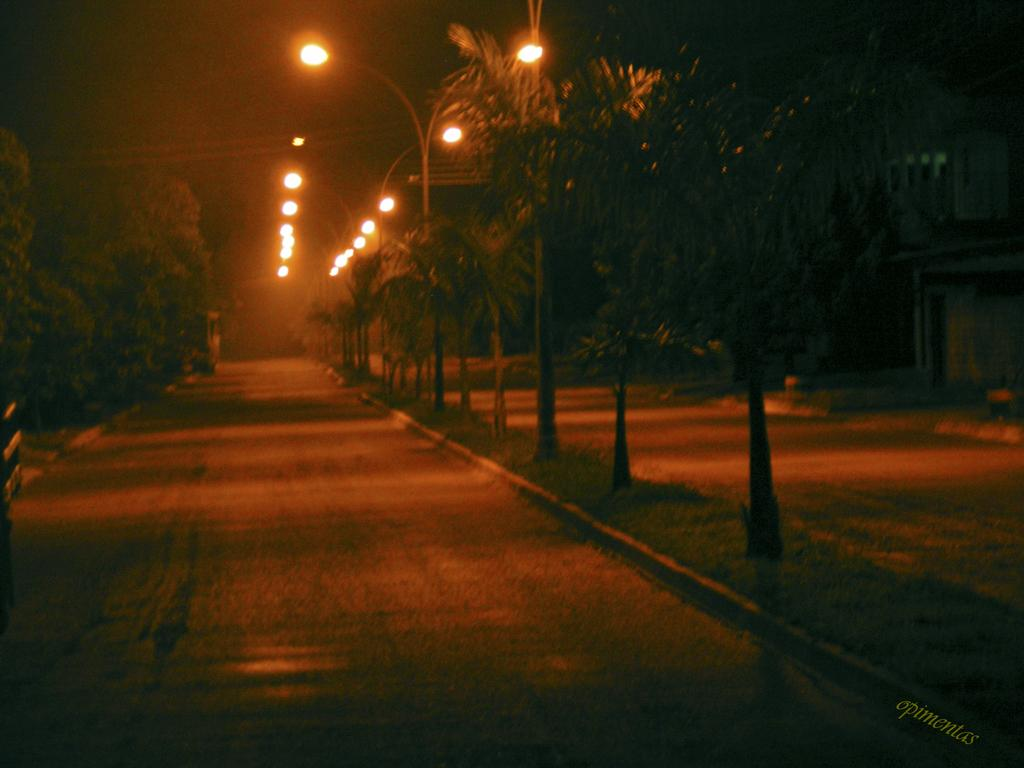What can be seen in the foreground area of the image? There are trees and a road in the foreground area of the image. What is visible in the background of the image? There are trees and lamps in the background of the image. What type of range is visible in the image? There is no range present in the image. Is the queen visible in the image? There is no queen present in the image. 